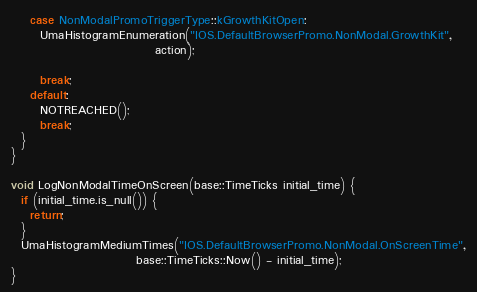Convert code to text. <code><loc_0><loc_0><loc_500><loc_500><_ObjectiveC_>    case NonModalPromoTriggerType::kGrowthKitOpen:
      UmaHistogramEnumeration("IOS.DefaultBrowserPromo.NonModal.GrowthKit",
                              action);

      break;
    default:
      NOTREACHED();
      break;
  }
}

void LogNonModalTimeOnScreen(base::TimeTicks initial_time) {
  if (initial_time.is_null()) {
    return;
  }
  UmaHistogramMediumTimes("IOS.DefaultBrowserPromo.NonModal.OnScreenTime",
                          base::TimeTicks::Now() - initial_time);
}
</code> 